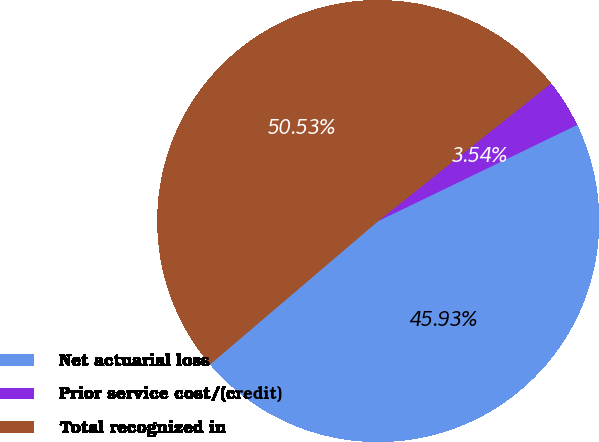Convert chart. <chart><loc_0><loc_0><loc_500><loc_500><pie_chart><fcel>Net actuarial loss<fcel>Prior service cost/(credit)<fcel>Total recognized in<nl><fcel>45.93%<fcel>3.54%<fcel>50.53%<nl></chart> 